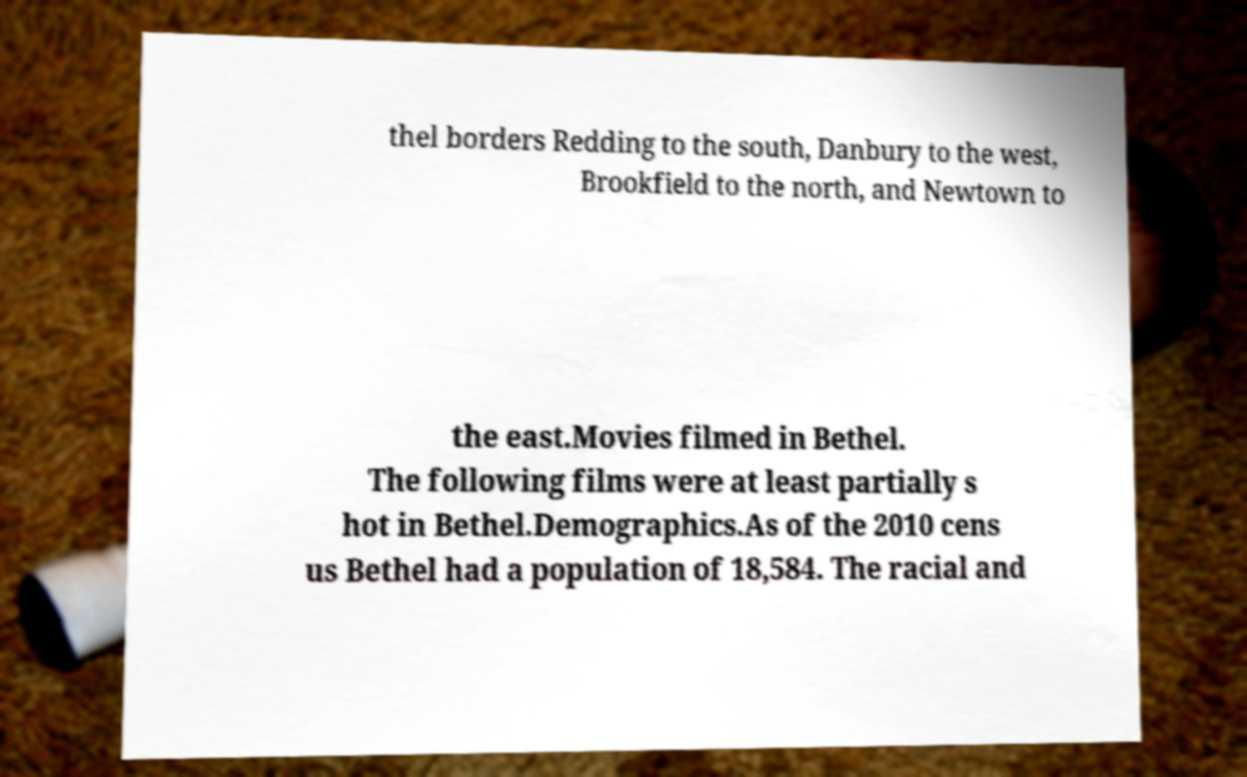Could you assist in decoding the text presented in this image and type it out clearly? thel borders Redding to the south, Danbury to the west, Brookfield to the north, and Newtown to the east.Movies filmed in Bethel. The following films were at least partially s hot in Bethel.Demographics.As of the 2010 cens us Bethel had a population of 18,584. The racial and 